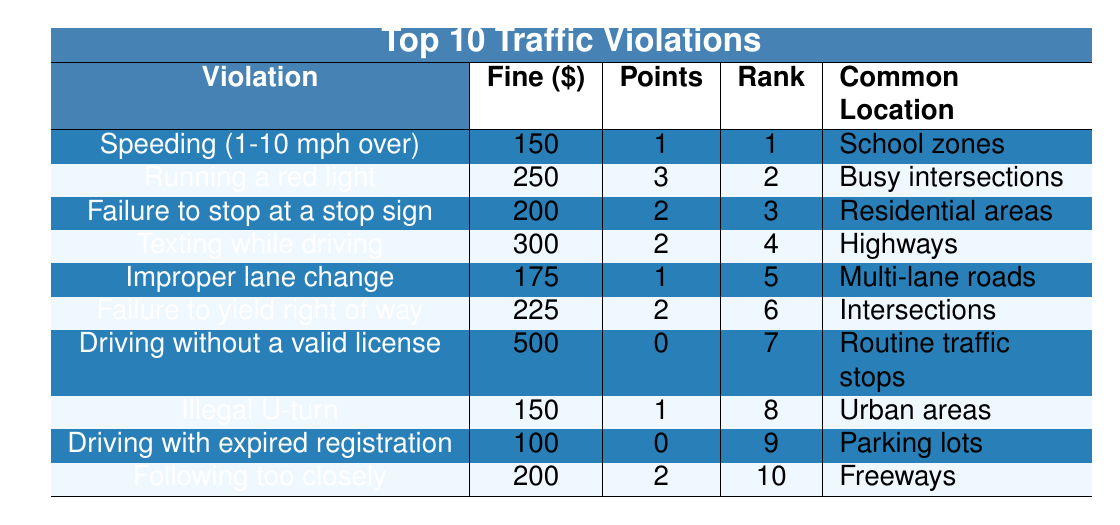What is the fine amount for texting while driving? The table shows that the fine amount for texting while driving is listed under the "Fine Amount" column next to the violation. It states $300.
Answer: 300 What are the points on the license for running a red light? The points on the license for running a red light can be found in the "Points on License" column next to the violation "Running a red light," which indicates 3 points.
Answer: 3 How many violations have a fine amount greater than $200? To determine this, I will count the entries in the "Fine Amount" column that are greater than $200. These are running a red light ($250), texting while driving ($300), and failing to yield right of way ($225). This means there are 3 violations.
Answer: 3 Which violation has the highest fine, and what is that fine? The violation with the highest fine can be identified by looking at the "Fine Amount" column. The highest fine listed is $500 for driving without a valid license.
Answer: Driving without a valid license: 500 Is there a violation that has 0 points on the license? To answer this question, I will check the "Points on License" column for any entries with 0 points. The entry for "Driving without a valid license" shows 0 points. Therefore, yes, there is such a violation.
Answer: Yes Calculate the average fine amount for all the violations listed. To find the average fine, I will sum up the fine amounts: 150 + 250 + 200 + 300 + 175 + 225 + 500 + 150 + 100 + 200 = 2250. There are 10 violations, so the average fine is 2250 / 10 = 225.
Answer: 225 Which violation occurs most frequently according to the rank? The rank is listed in the "Frequency Rank" column. The highest rank (1) corresponds to the violation "Speeding (1-10 mph over)," meaning it is the most frequently cited violation.
Answer: Speeding (1-10 mph over) What location is commonly cited for failure to yield the right of way? To find the location commonly cited for failure to yield the right of way, I will look under the "Commonly Cited Location" column next to the corresponding violation. It states "Intersections."
Answer: Intersections How many total points would you accumulate if you commit following too closely and not stopping at a stop sign? I will add the points from the "Points on License" column for "Following too closely" (2 points) and "Failure to stop at a stop sign" (2 points). The total points would be 2 + 2 = 4.
Answer: 4 Determine if there are any violations with a fine of $150. I will check the "Fine Amount" column for any entries equal to $150. The violations "Speeding (1-10 mph over)" and "Illegal U-turn" both have fines of $150, so there are indeed violations with that fine.
Answer: Yes 